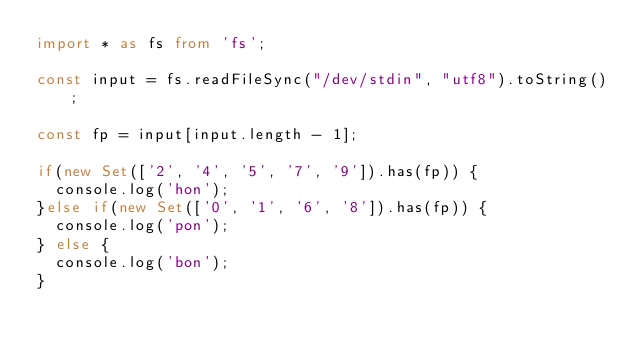<code> <loc_0><loc_0><loc_500><loc_500><_TypeScript_>import * as fs from 'fs';
 
const input = fs.readFileSync("/dev/stdin", "utf8").toString();

const fp = input[input.length - 1];
 
if(new Set(['2', '4', '5', '7', '9']).has(fp)) {
  console.log('hon');
}else if(new Set(['0', '1', '6', '8']).has(fp)) {
  console.log('pon');
} else {
  console.log('bon');
}</code> 